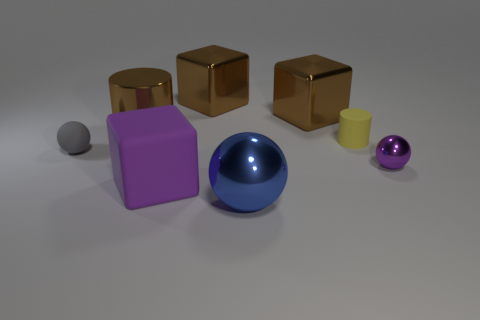How many other things are there of the same size as the rubber cylinder?
Keep it short and to the point. 2. Does the small metal thing have the same color as the big object in front of the large matte thing?
Offer a terse response. No. Are there fewer tiny yellow objects in front of the blue shiny sphere than large brown things behind the brown cylinder?
Give a very brief answer. Yes. There is a large thing that is right of the purple rubber cube and in front of the small metal sphere; what color is it?
Provide a short and direct response. Blue. There is a gray matte thing; does it have the same size as the cylinder to the left of the small rubber cylinder?
Your response must be concise. No. There is a matte thing behind the tiny gray matte sphere; what shape is it?
Your answer should be very brief. Cylinder. Is there anything else that is made of the same material as the gray object?
Offer a very short reply. Yes. Is the number of big brown shiny cubes in front of the purple ball greater than the number of brown cylinders?
Offer a very short reply. No. There is a metal sphere that is on the left side of the small ball that is in front of the small gray thing; how many spheres are behind it?
Offer a very short reply. 2. Do the thing on the left side of the large metal cylinder and the cylinder that is on the left side of the big purple rubber thing have the same size?
Ensure brevity in your answer.  No. 